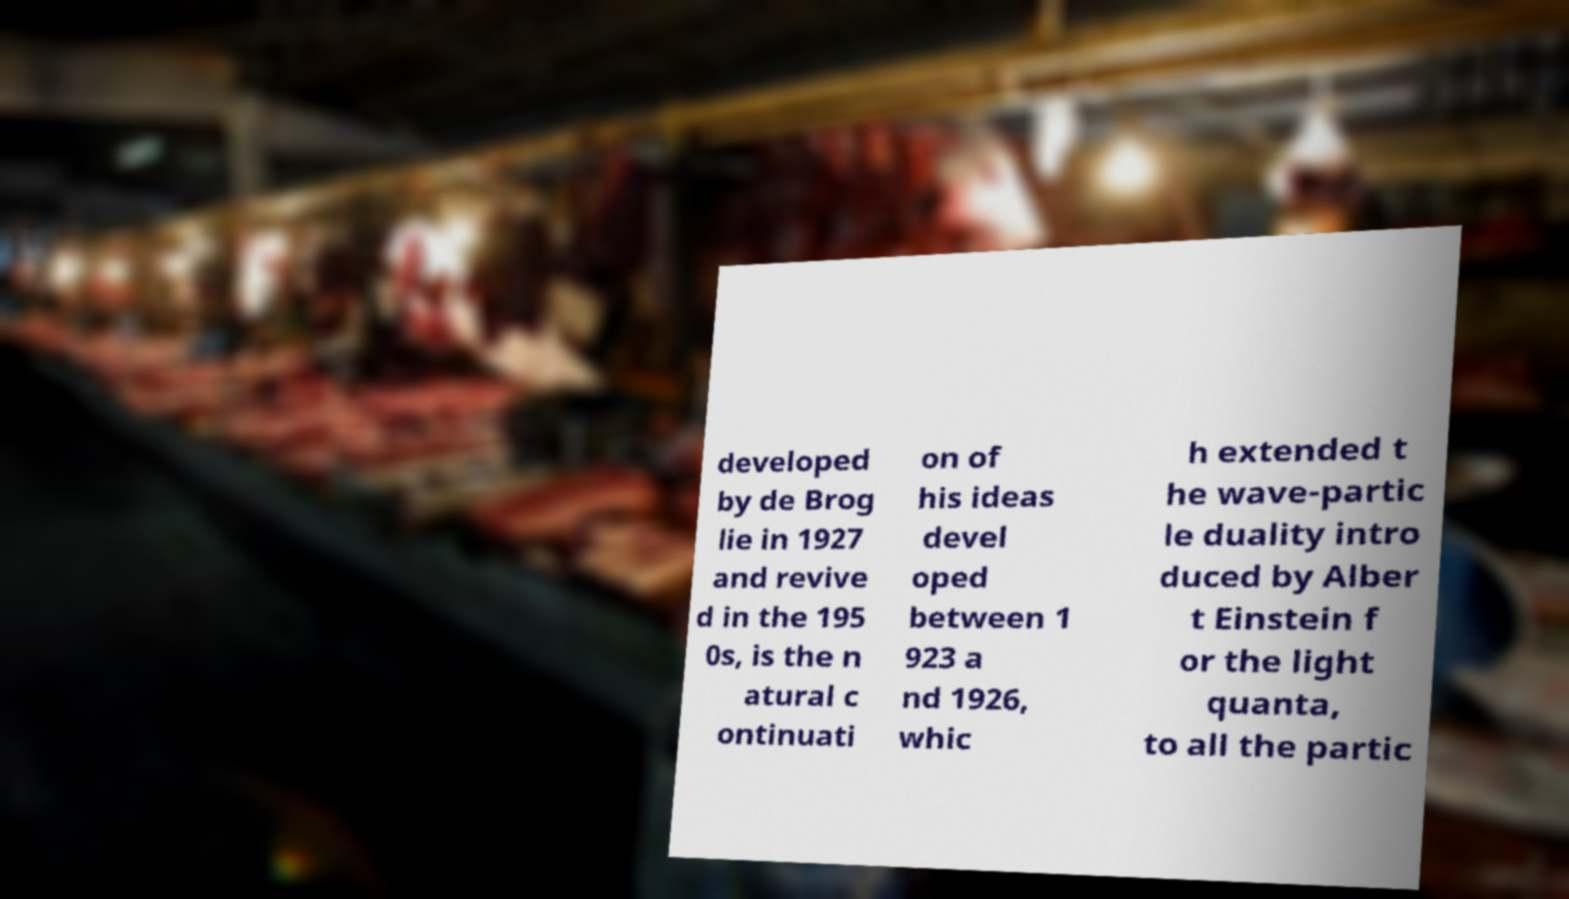Could you assist in decoding the text presented in this image and type it out clearly? developed by de Brog lie in 1927 and revive d in the 195 0s, is the n atural c ontinuati on of his ideas devel oped between 1 923 a nd 1926, whic h extended t he wave-partic le duality intro duced by Alber t Einstein f or the light quanta, to all the partic 